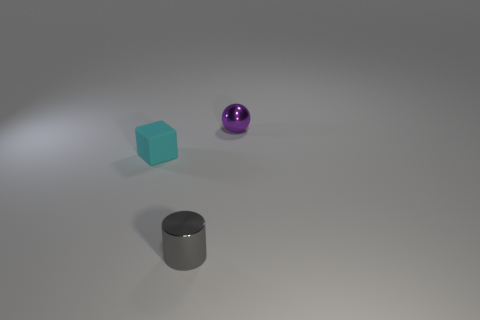Are there any other things that have the same shape as the small rubber thing?
Offer a terse response. No. There is a object behind the cyan rubber thing; is its size the same as the cyan matte thing?
Your response must be concise. Yes. What number of other objects are the same material as the small cyan block?
Your answer should be compact. 0. Are there more tiny cyan matte cubes than things?
Provide a succinct answer. No. What is the material of the tiny object that is to the right of the tiny metal thing that is in front of the small cyan rubber object that is on the left side of the gray object?
Give a very brief answer. Metal. What shape is the cyan thing that is the same size as the purple ball?
Ensure brevity in your answer.  Cube. Is the number of purple objects less than the number of small brown objects?
Give a very brief answer. No. How many gray matte balls have the same size as the matte block?
Ensure brevity in your answer.  0. What is the sphere made of?
Give a very brief answer. Metal. How many other small things have the same shape as the tiny matte object?
Give a very brief answer. 0. 